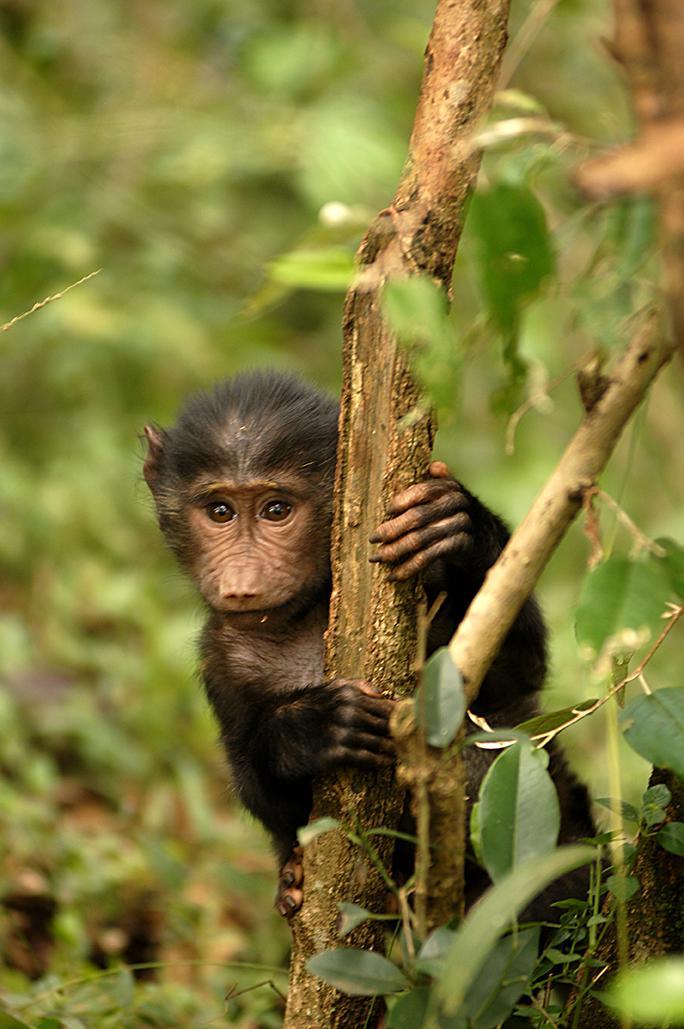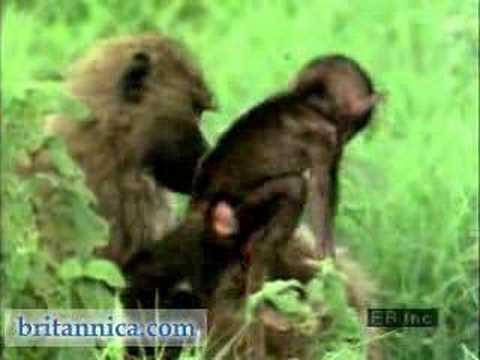The first image is the image on the left, the second image is the image on the right. Assess this claim about the two images: "There are three monkeys in the pair of images.". Correct or not? Answer yes or no. Yes. The first image is the image on the left, the second image is the image on the right. Analyze the images presented: Is the assertion "An image includes a leftward-moving adult baboon walking on all fours, and each image includes one baboon on all fours." valid? Answer yes or no. No. 